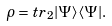<formula> <loc_0><loc_0><loc_500><loc_500>\rho = t r _ { 2 } | \Psi \rangle \langle \Psi | .</formula> 